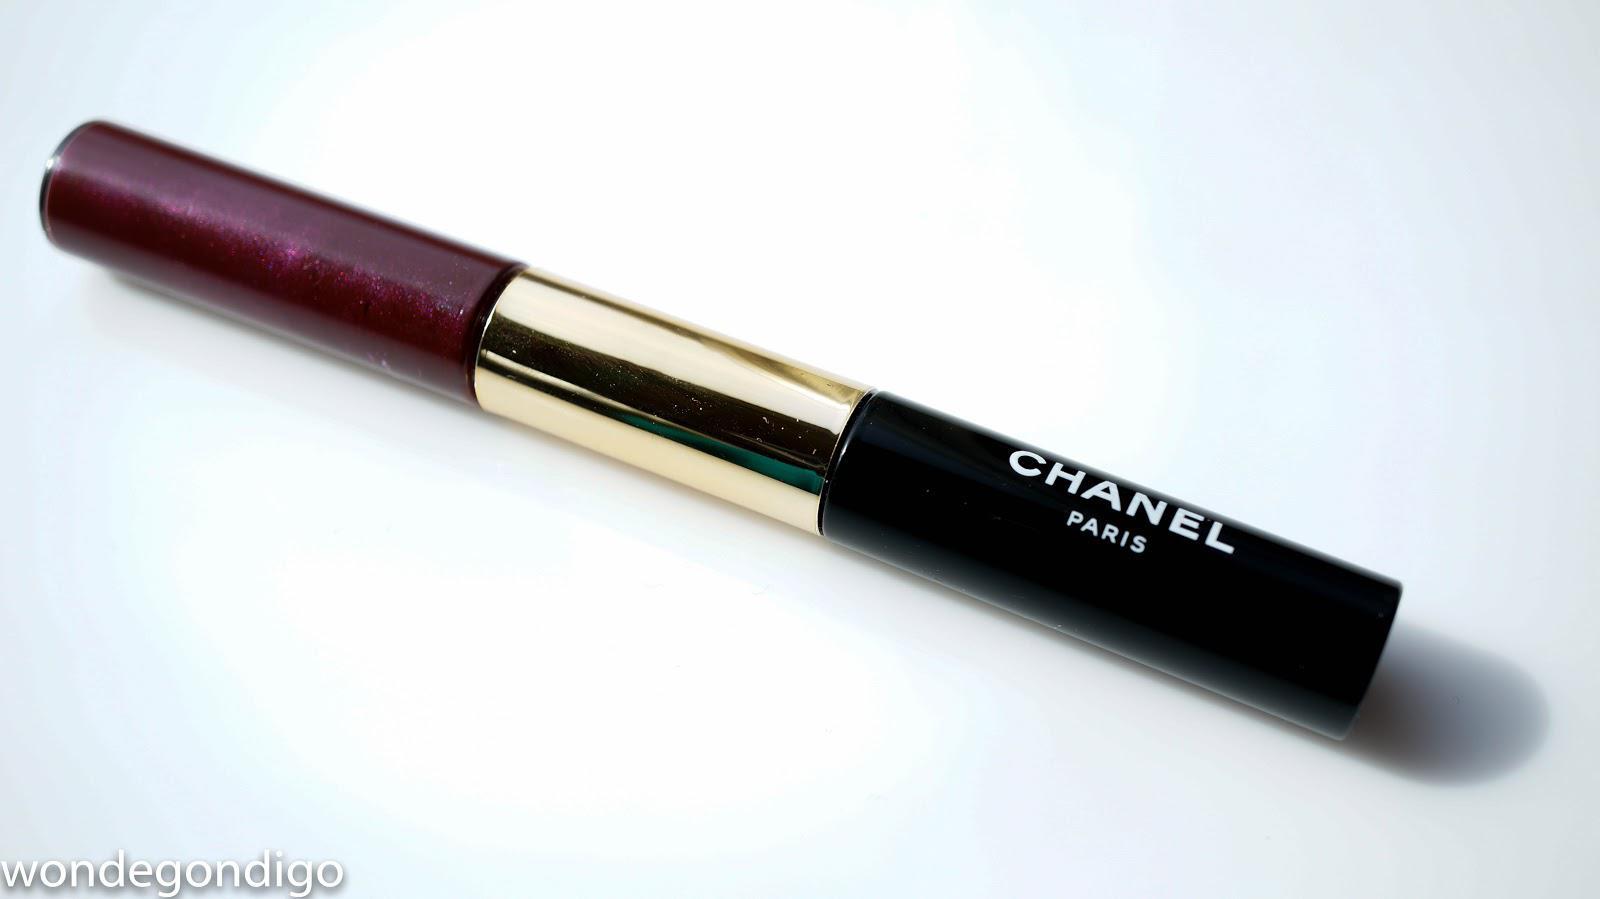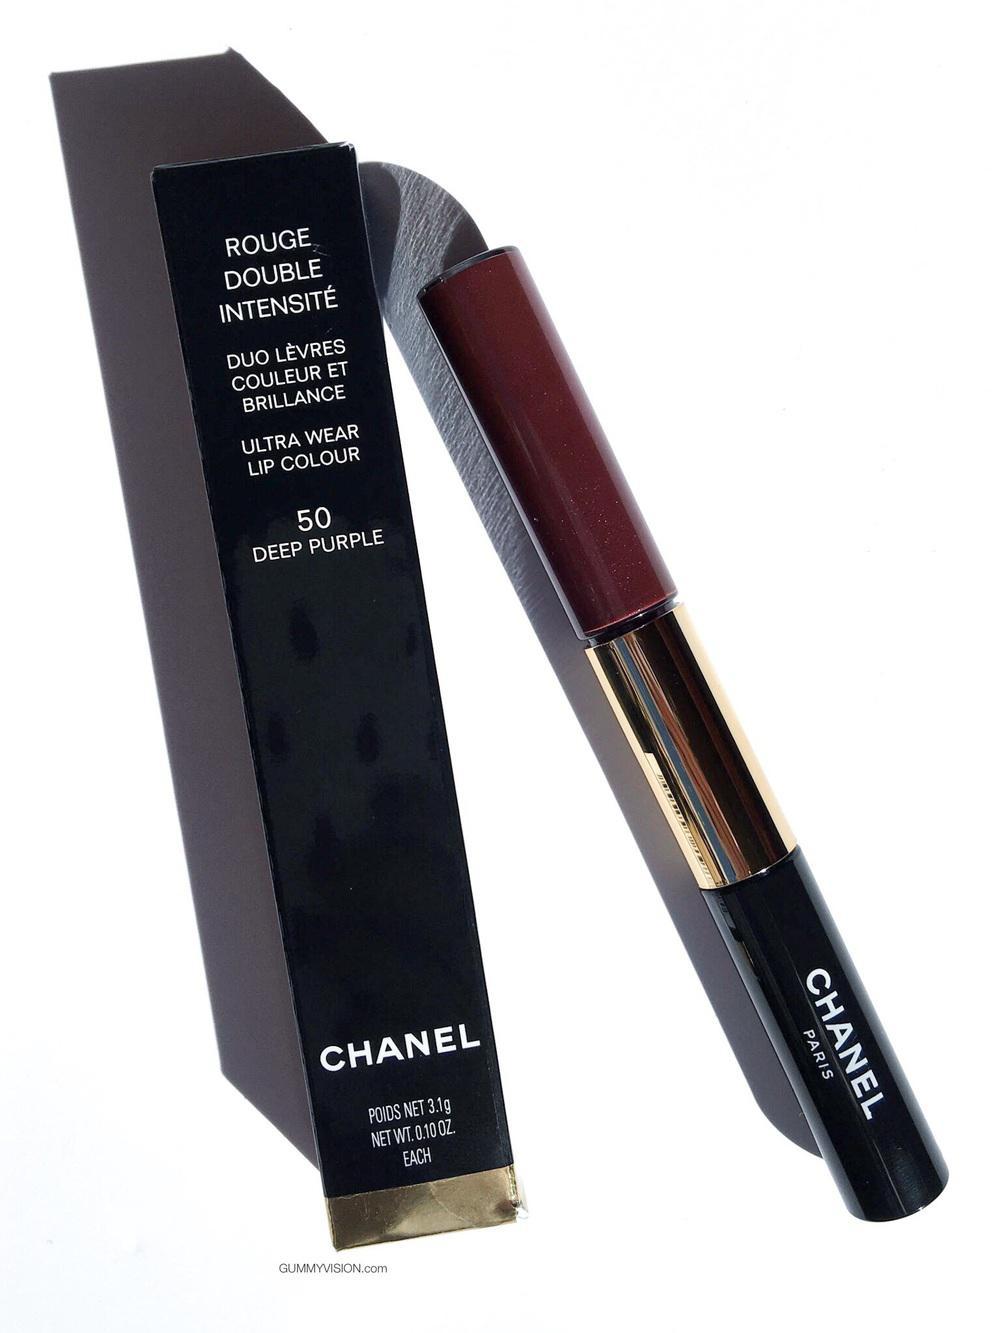The first image is the image on the left, the second image is the image on the right. For the images displayed, is the sentence "All lip makeups shown come in cylindrical bottles with clear glass that shows the reddish-purple color of the lip tint." factually correct? Answer yes or no. Yes. 